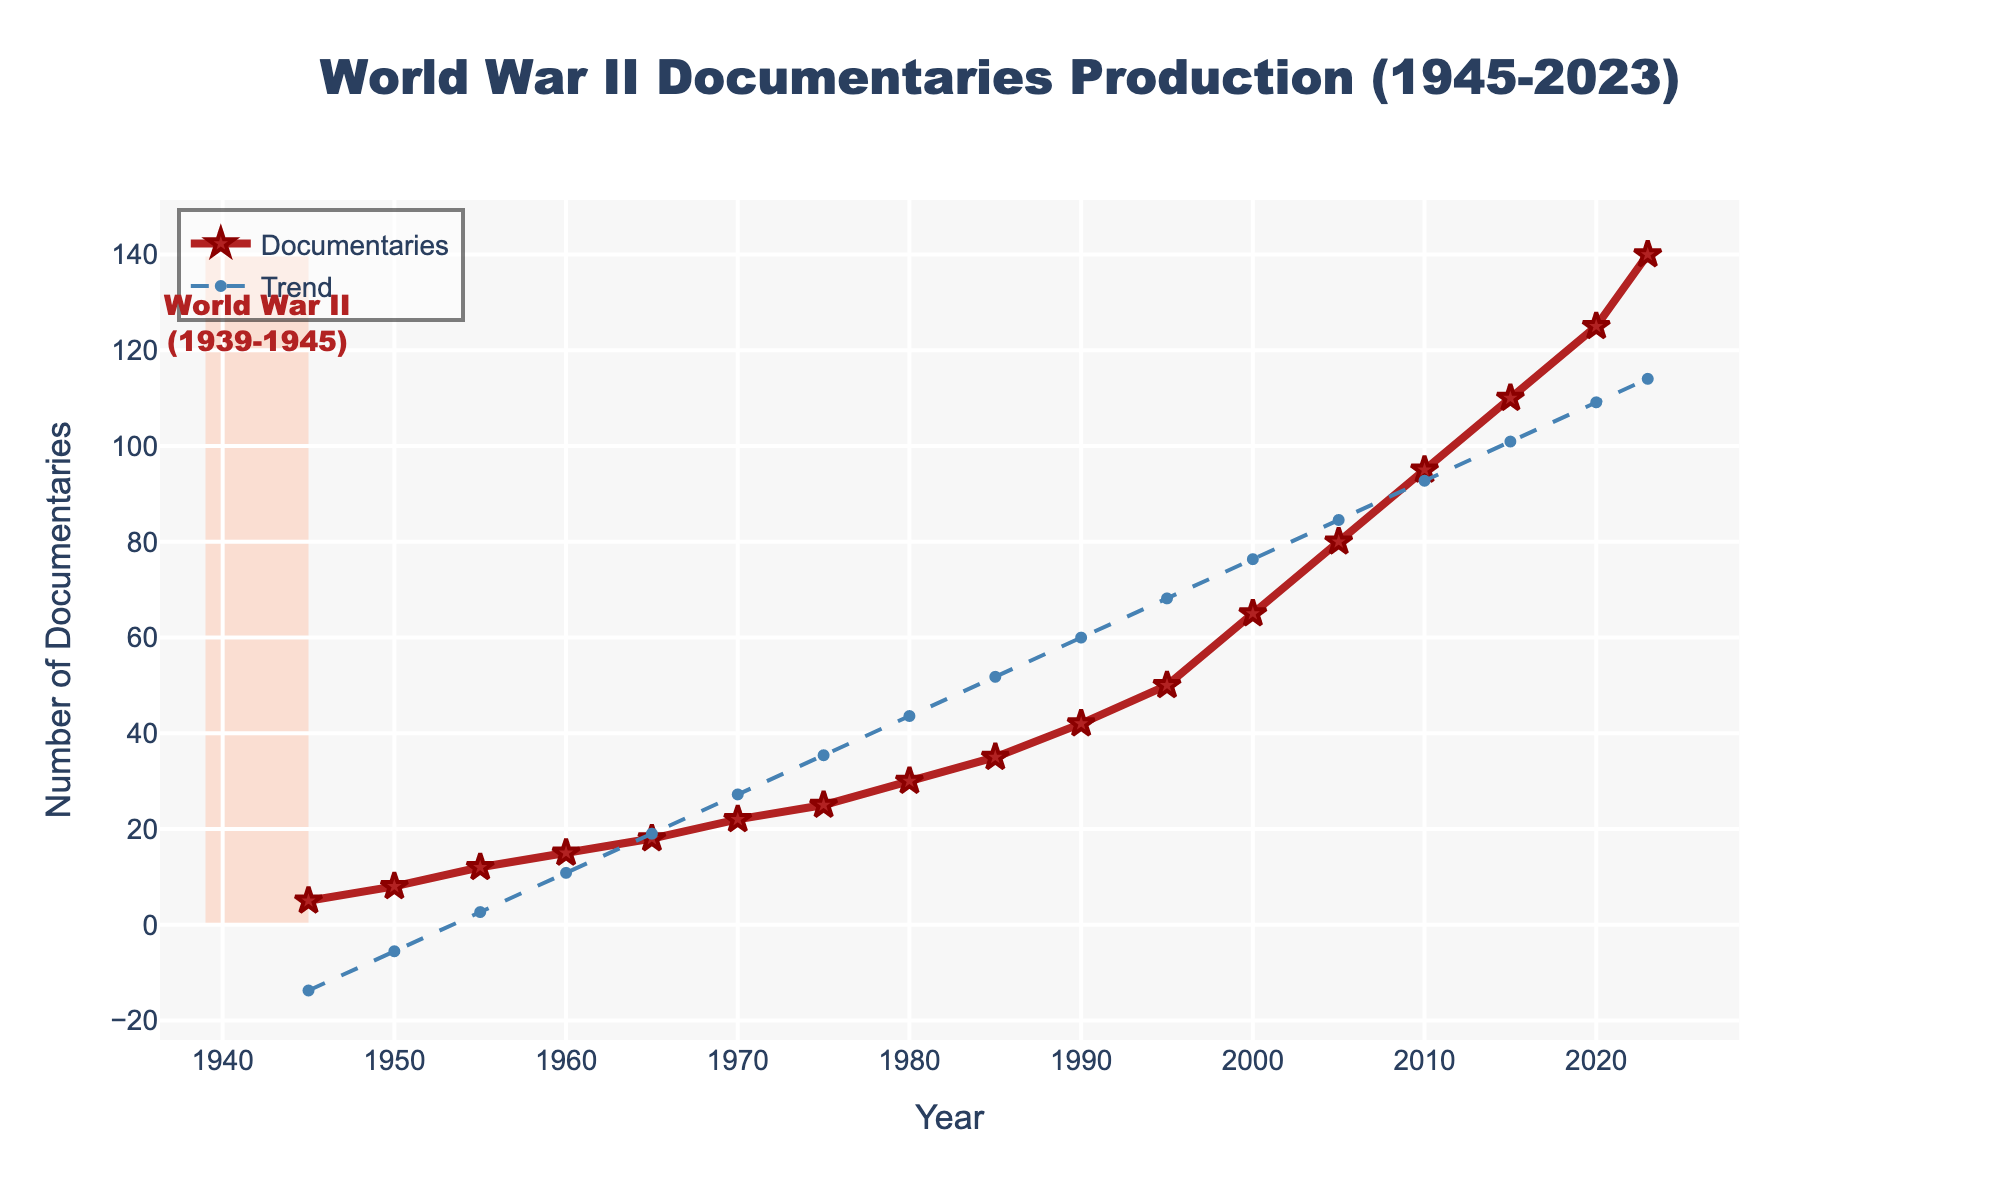What is the trend in the production of World War II documentaries from 1945 to 2023? By observing the trendline, which has been added to the plot using a dashed blue line, we can see that the number of documentaries produced per year has been steadily increasing over time.
Answer: Increasing During which period did the production of documentaries first exceed 50 per year? By looking at the y-axis, we can see that the number of documentaries first exceeded 50 in the year 1995.
Answer: 1995 Compare the number of documentaries produced in 1950 with those in 2023. How much greater is the number in 2023? In 1950, 8 documentaries were produced, while in 2023, 140 were produced. The difference is 140 - 8 = 132.
Answer: 132 How many times did the number of documentaries produced double from 1945 to 2023? In 1945, the number of documentaries produced was 5. Doubling 5 results in 10, and the number doubles from 5 to 10 between 1950 and 1955. Similarly, doubling from 10 results in 20, then to 40, 80, and finally 160. We can track this through the plot, seeing the increments in 1960, 1985, 2005, and towards 2023, though not exactly doubled. Doubling occurred approximately 4 times (by approximating to nearest decades).
Answer: 4 times What is the overall increase in the number of documentaries produced from 1945 to 2023? By subtracting the number of documentaries produced in 1945 (5) from the number produced in 2023 (140), we find the overall increase: 140 - 5 = 135.
Answer: 135 Which year depicted in the figure has the steepest increase in the number of documentaries compared to its previous year? By visually inspecting the plot, the steepest increase appears between 2000 and 2005. The number of documentaries increased from 65 to 80, an increase of 15.
Answer: 2000 to 2005 What color and shape are used to represent the number of documentaries produced each year? The documentaries are represented by red lines connecting star-shaped markers.
Answer: Red lines and star-shaped markers How does the production trend before and after the year 2000 compare? Before the year 2000, the trend shows a steady increase, especially notable post-1980. After 2000, the number of documentaries shows a sharper rise, illustrated by the steep incline in the trendline.
Answer: Sharper rise after 2000 